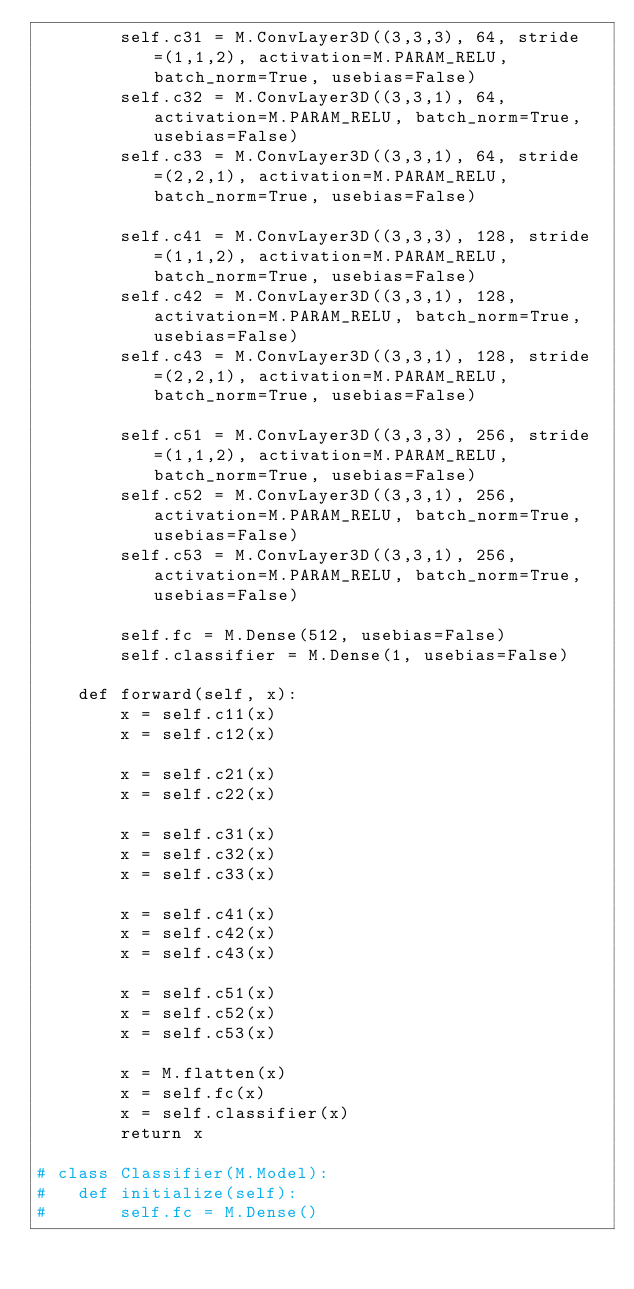Convert code to text. <code><loc_0><loc_0><loc_500><loc_500><_Python_>		self.c31 = M.ConvLayer3D((3,3,3), 64, stride=(1,1,2), activation=M.PARAM_RELU, batch_norm=True, usebias=False)
		self.c32 = M.ConvLayer3D((3,3,1), 64, activation=M.PARAM_RELU, batch_norm=True, usebias=False)
		self.c33 = M.ConvLayer3D((3,3,1), 64, stride=(2,2,1), activation=M.PARAM_RELU, batch_norm=True, usebias=False)

		self.c41 = M.ConvLayer3D((3,3,3), 128, stride=(1,1,2), activation=M.PARAM_RELU, batch_norm=True, usebias=False)
		self.c42 = M.ConvLayer3D((3,3,1), 128, activation=M.PARAM_RELU, batch_norm=True, usebias=False)
		self.c43 = M.ConvLayer3D((3,3,1), 128, stride=(2,2,1), activation=M.PARAM_RELU, batch_norm=True, usebias=False)

		self.c51 = M.ConvLayer3D((3,3,3), 256, stride=(1,1,2), activation=M.PARAM_RELU, batch_norm=True, usebias=False)
		self.c52 = M.ConvLayer3D((3,3,1), 256, activation=M.PARAM_RELU, batch_norm=True, usebias=False)
		self.c53 = M.ConvLayer3D((3,3,1), 256, activation=M.PARAM_RELU, batch_norm=True, usebias=False)

		self.fc = M.Dense(512, usebias=False)
		self.classifier = M.Dense(1, usebias=False)

	def forward(self, x):
		x = self.c11(x)
		x = self.c12(x)

		x = self.c21(x)
		x = self.c22(x)

		x = self.c31(x)
		x = self.c32(x)
		x = self.c33(x)

		x = self.c41(x)
		x = self.c42(x)
		x = self.c43(x)

		x = self.c51(x)
		x = self.c52(x)
		x = self.c53(x)

		x = M.flatten(x)
		x = self.fc(x)
		x = self.classifier(x)
		return x 

# class Classifier(M.Model):
# 	def initialize(self):
# 		self.fc = M.Dense()</code> 